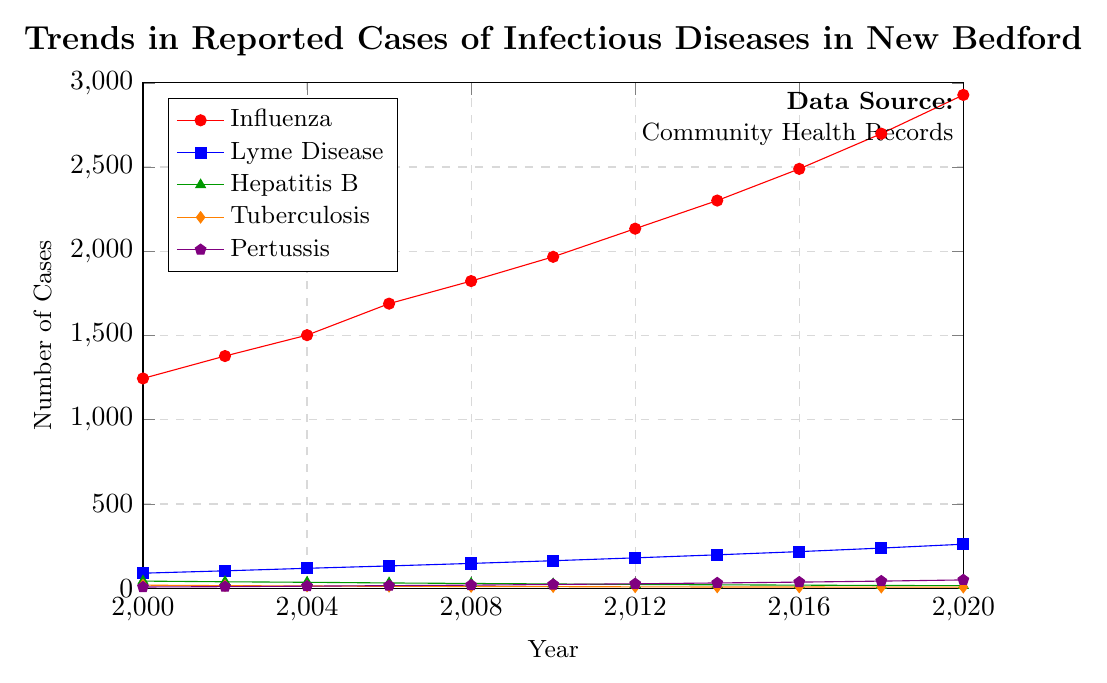Which disease had the highest number of reported cases in 2020? By observing the y-axis values corresponding to 2020 for each colored line, Influenza had the highest number of cases at 2928.
Answer: Influenza What is the overall trend of Tuberculosis cases from 2000 to 2020? The plot shows a decreasing trend in Tuberculosis cases from 18 in 2000 to 6 in 2020.
Answer: Decreasing How many more cases of Lyme Disease were reported in 2020 compared to 2000? Subtract the number of Lyme Disease cases in 2000 (89) from the number in 2020 (261) to find the difference. 261 - 89 = 172.
Answer: 172 Compare the trends of Pertussis and Influenza from 2000 to 2020. Both diseases show an increasing trend, but Influenza's increase is more significant, starting at 1245 in 2000 and reaching 2928 in 2020, while Pertussis starts at 7 and reaches 49.
Answer: Both increasing, Influenza more significantly What is the average number of Hepatitis B cases reported from 2000 to 2020? Sum the Hepatitis B cases from all years and divide by the number of years: (42+38+35+31+28+25+22+20+18+16+15)/11 = 27.
Answer: 27 Between which consecutive years did Influenza see the largest increase in reported cases? Calculate the difference between consecutive years: 2002-2000 (133), 2004-2002 (124), 2006-2004 (187), 2008-2006 (134), 2010-2008 (144), 2012-2010 (167), 2014-2012 (167), 2016-2014 (188), 2018-2016 (209), 2020-2018 (230). The largest increase is from 2018 to 2020 with 230 cases.
Answer: 2018 to 2020 How do the trends of Hepatitis B and Tuberculosis compare over the years? Both diseases show a decreasing trend over the years, with Hepatitis B cases decreasing from 42 in 2000 to 15 in 2020, and Tuberculosis from 18 to 6.
Answer: Both decreasing Which disease showed the most steady increase over the period? By observing the slopes of the trend lines, Lyme Disease shows a steady linear increase from 89 in 2000 to 261 in 2020.
Answer: Lyme Disease What is the total number of reported Pertussis cases from 2000 to 2020? Sum the number of Pertussis cases from each year: 7+9+12+15+18+22+26+31+36+42+49 = 267.
Answer: 267 Which year had the highest number of reported Lyme Disease cases and how many were there? The year 2020 had the highest number of Lyme Disease cases with 261.
Answer: 2020, 261 